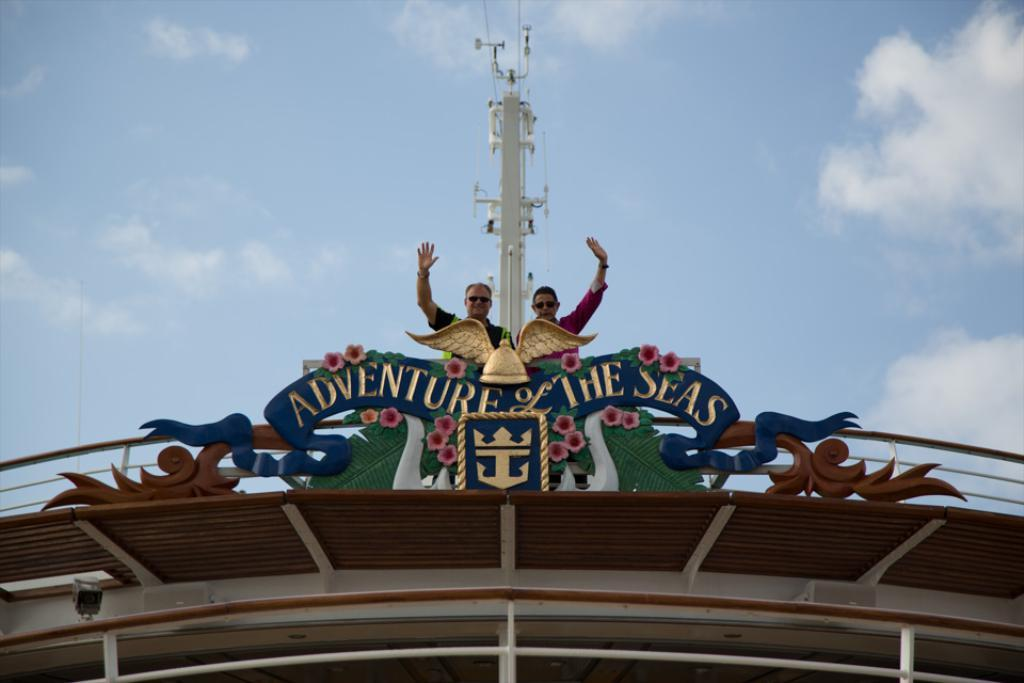How many people are in the image? There are two persons in the image. Where are the persons located in the image? The persons are on a deck. What can be seen in the background of the image? There is a sky visible in the background of the image. What type of knife is being used by one of the persons in the image? There is no knife present in the image; only two persons on a deck are visible. 